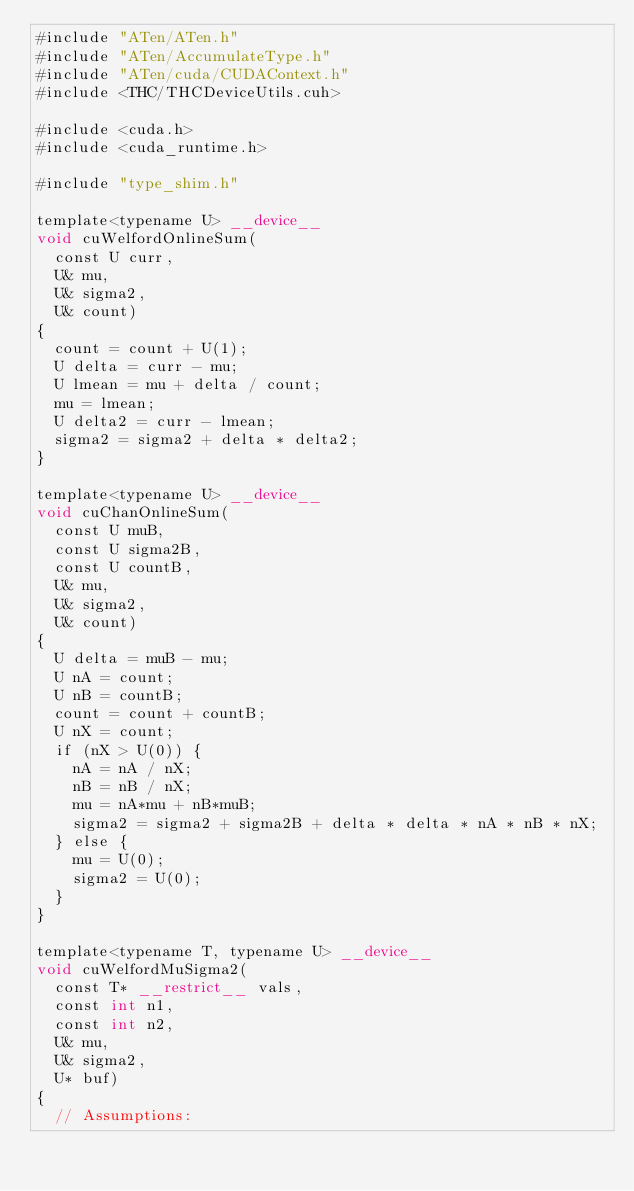<code> <loc_0><loc_0><loc_500><loc_500><_Cuda_>#include "ATen/ATen.h"
#include "ATen/AccumulateType.h"
#include "ATen/cuda/CUDAContext.h"
#include <THC/THCDeviceUtils.cuh>

#include <cuda.h>
#include <cuda_runtime.h>

#include "type_shim.h"

template<typename U> __device__
void cuWelfordOnlineSum(
  const U curr,
  U& mu,
  U& sigma2,
  U& count)
{
  count = count + U(1);
  U delta = curr - mu;
  U lmean = mu + delta / count;
  mu = lmean;
  U delta2 = curr - lmean;
  sigma2 = sigma2 + delta * delta2;
}

template<typename U> __device__
void cuChanOnlineSum(
  const U muB,
  const U sigma2B,
  const U countB,
  U& mu,
  U& sigma2,
  U& count)
{
  U delta = muB - mu;
  U nA = count;
  U nB = countB;
  count = count + countB;
  U nX = count;
  if (nX > U(0)) {
    nA = nA / nX;
    nB = nB / nX;
    mu = nA*mu + nB*muB;
    sigma2 = sigma2 + sigma2B + delta * delta * nA * nB * nX;
  } else {
    mu = U(0);
    sigma2 = U(0);
  }
}

template<typename T, typename U> __device__
void cuWelfordMuSigma2(
  const T* __restrict__ vals,
  const int n1,
  const int n2,
  U& mu,
  U& sigma2,
  U* buf) 
{
  // Assumptions:</code> 